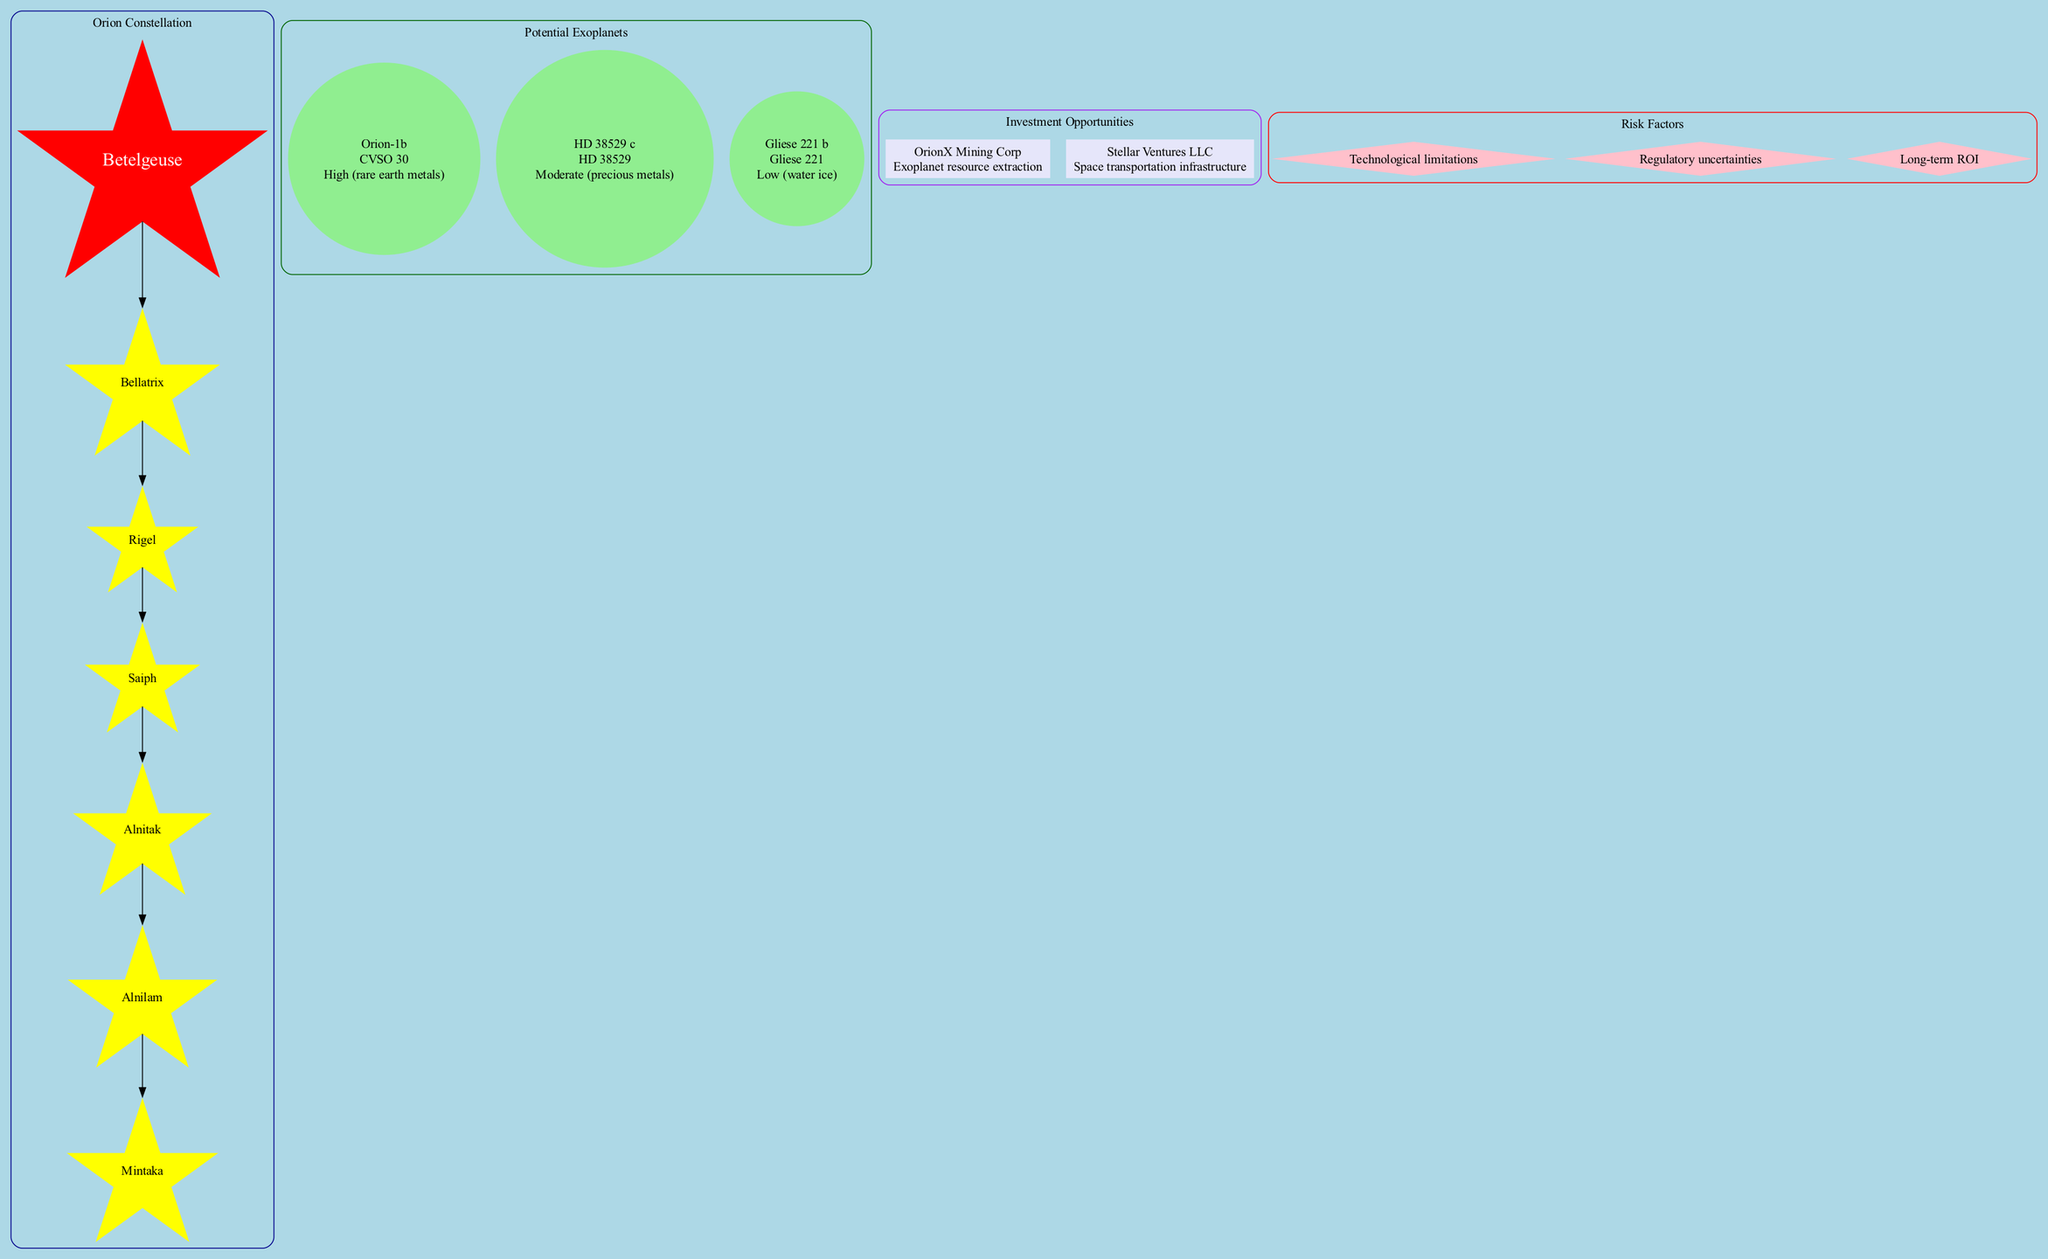What is the central star of the Orion constellation? The diagram identifies Betelgeuse as the central star of the Orion constellation.
Answer: Betelgeuse How many potential exoplanets are listed in the diagram? The diagram shows three potential exoplanets: Orion-1b, HD 38529 c, and Gliese 221 b. Counting these gives us a total of three exoplanets.
Answer: 3 What is the mining potential of Orion-1b? The diagram states that Orion-1b has a high mining potential due to the presence of rare earth metals.
Answer: High (rare earth metals) Which company focuses on space transportation infrastructure? The diagram lists Stellar Ventures LLC as the company that focuses on space transportation infrastructure.
Answer: Stellar Ventures LLC Which star is associated with the exoplanet Gliese 221 b? The diagram indicates that Gliese 221 b is associated with the star Gliese 221. This connection can be traced from the exoplanet to its respective star.
Answer: Gliese 221 What are the risk factors mentioned in the diagram? The diagram outlines three risk factors: Technological limitations, Regulatory uncertainties, and Long-term ROI. This can be found in the risk factors section of the diagram.
Answer: Technological limitations, Regulatory uncertainties, Long-term ROI What is the relationship between Betelgeuse and Rigel? The diagram shows a direct connection (edge) from Betelgeuse to Bellatrix, and then from Bellatrix to Rigel, indicating a sequential relationship through the Orion constellation.
Answer: Rigidly connected (via Bellatrix) Which exoplanet has moderate mining potential? The diagram states HD 38529 c has moderate mining potential, specifically related to precious metals. This information is contained within the exoplanets section.
Answer: HD 38529 c How many stars are part of the Orion constellation shown in the diagram? The diagram lists six stars as part of the Orion constellation, which are Rigel, Bellatrix, Saiph, Mintaka, Alnilam, and Alnitak. We get this count directly from the constellation elements list.
Answer: 6 